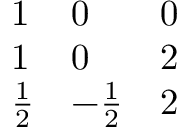Convert formula to latex. <formula><loc_0><loc_0><loc_500><loc_500>\begin{array} { l l l } { 1 } & { 0 } & { 0 } \\ { 1 } & { 0 } & { 2 } \\ { { { \frac { 1 } { 2 } } } } & { { - { \frac { 1 } { 2 } } } } & { 2 } \end{array}</formula> 